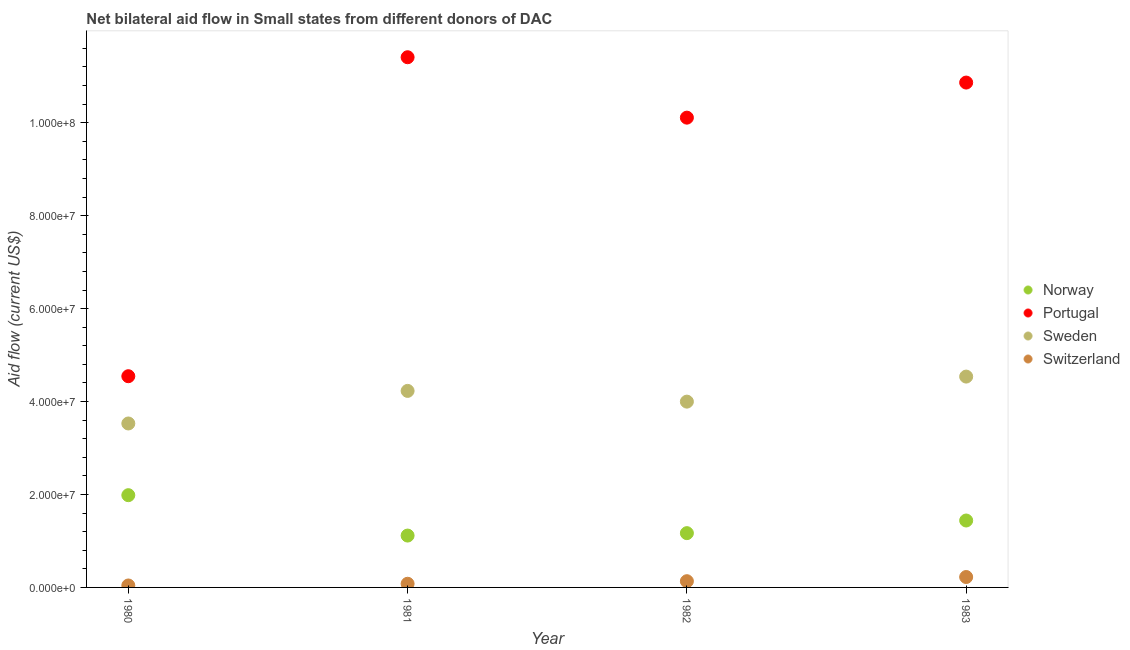What is the amount of aid given by switzerland in 1981?
Provide a succinct answer. 7.90e+05. Across all years, what is the maximum amount of aid given by sweden?
Offer a terse response. 4.54e+07. Across all years, what is the minimum amount of aid given by norway?
Make the answer very short. 1.12e+07. What is the total amount of aid given by portugal in the graph?
Your answer should be very brief. 3.69e+08. What is the difference between the amount of aid given by sweden in 1980 and that in 1983?
Make the answer very short. -1.01e+07. What is the difference between the amount of aid given by norway in 1981 and the amount of aid given by switzerland in 1983?
Make the answer very short. 8.92e+06. What is the average amount of aid given by portugal per year?
Offer a very short reply. 9.23e+07. In the year 1983, what is the difference between the amount of aid given by norway and amount of aid given by portugal?
Offer a very short reply. -9.42e+07. In how many years, is the amount of aid given by switzerland greater than 20000000 US$?
Make the answer very short. 0. What is the ratio of the amount of aid given by portugal in 1980 to that in 1982?
Ensure brevity in your answer.  0.45. Is the difference between the amount of aid given by sweden in 1980 and 1982 greater than the difference between the amount of aid given by norway in 1980 and 1982?
Your answer should be very brief. No. What is the difference between the highest and the lowest amount of aid given by sweden?
Keep it short and to the point. 1.01e+07. Is it the case that in every year, the sum of the amount of aid given by norway and amount of aid given by sweden is greater than the sum of amount of aid given by portugal and amount of aid given by switzerland?
Your response must be concise. Yes. Is the amount of aid given by sweden strictly less than the amount of aid given by portugal over the years?
Your response must be concise. Yes. How many years are there in the graph?
Give a very brief answer. 4. What is the difference between two consecutive major ticks on the Y-axis?
Provide a succinct answer. 2.00e+07. Are the values on the major ticks of Y-axis written in scientific E-notation?
Ensure brevity in your answer.  Yes. Does the graph contain any zero values?
Your answer should be very brief. No. Where does the legend appear in the graph?
Offer a very short reply. Center right. How many legend labels are there?
Keep it short and to the point. 4. How are the legend labels stacked?
Make the answer very short. Vertical. What is the title of the graph?
Offer a very short reply. Net bilateral aid flow in Small states from different donors of DAC. What is the label or title of the X-axis?
Ensure brevity in your answer.  Year. What is the label or title of the Y-axis?
Provide a succinct answer. Aid flow (current US$). What is the Aid flow (current US$) in Norway in 1980?
Provide a succinct answer. 1.98e+07. What is the Aid flow (current US$) of Portugal in 1980?
Ensure brevity in your answer.  4.54e+07. What is the Aid flow (current US$) of Sweden in 1980?
Your answer should be compact. 3.53e+07. What is the Aid flow (current US$) of Switzerland in 1980?
Your response must be concise. 4.20e+05. What is the Aid flow (current US$) in Norway in 1981?
Your answer should be compact. 1.12e+07. What is the Aid flow (current US$) in Portugal in 1981?
Make the answer very short. 1.14e+08. What is the Aid flow (current US$) of Sweden in 1981?
Your answer should be compact. 4.23e+07. What is the Aid flow (current US$) of Switzerland in 1981?
Make the answer very short. 7.90e+05. What is the Aid flow (current US$) of Norway in 1982?
Give a very brief answer. 1.17e+07. What is the Aid flow (current US$) in Portugal in 1982?
Offer a terse response. 1.01e+08. What is the Aid flow (current US$) of Sweden in 1982?
Offer a very short reply. 4.00e+07. What is the Aid flow (current US$) in Switzerland in 1982?
Provide a succinct answer. 1.34e+06. What is the Aid flow (current US$) in Norway in 1983?
Ensure brevity in your answer.  1.44e+07. What is the Aid flow (current US$) in Portugal in 1983?
Give a very brief answer. 1.09e+08. What is the Aid flow (current US$) of Sweden in 1983?
Ensure brevity in your answer.  4.54e+07. What is the Aid flow (current US$) of Switzerland in 1983?
Keep it short and to the point. 2.24e+06. Across all years, what is the maximum Aid flow (current US$) in Norway?
Keep it short and to the point. 1.98e+07. Across all years, what is the maximum Aid flow (current US$) in Portugal?
Keep it short and to the point. 1.14e+08. Across all years, what is the maximum Aid flow (current US$) of Sweden?
Offer a terse response. 4.54e+07. Across all years, what is the maximum Aid flow (current US$) in Switzerland?
Provide a succinct answer. 2.24e+06. Across all years, what is the minimum Aid flow (current US$) of Norway?
Your answer should be very brief. 1.12e+07. Across all years, what is the minimum Aid flow (current US$) in Portugal?
Offer a terse response. 4.54e+07. Across all years, what is the minimum Aid flow (current US$) in Sweden?
Ensure brevity in your answer.  3.53e+07. What is the total Aid flow (current US$) of Norway in the graph?
Provide a succinct answer. 5.71e+07. What is the total Aid flow (current US$) in Portugal in the graph?
Offer a very short reply. 3.69e+08. What is the total Aid flow (current US$) of Sweden in the graph?
Keep it short and to the point. 1.63e+08. What is the total Aid flow (current US$) in Switzerland in the graph?
Your answer should be compact. 4.79e+06. What is the difference between the Aid flow (current US$) of Norway in 1980 and that in 1981?
Offer a very short reply. 8.69e+06. What is the difference between the Aid flow (current US$) of Portugal in 1980 and that in 1981?
Your answer should be very brief. -6.86e+07. What is the difference between the Aid flow (current US$) of Sweden in 1980 and that in 1981?
Provide a short and direct response. -7.01e+06. What is the difference between the Aid flow (current US$) in Switzerland in 1980 and that in 1981?
Provide a succinct answer. -3.70e+05. What is the difference between the Aid flow (current US$) of Norway in 1980 and that in 1982?
Your answer should be compact. 8.17e+06. What is the difference between the Aid flow (current US$) of Portugal in 1980 and that in 1982?
Provide a short and direct response. -5.56e+07. What is the difference between the Aid flow (current US$) of Sweden in 1980 and that in 1982?
Your response must be concise. -4.70e+06. What is the difference between the Aid flow (current US$) in Switzerland in 1980 and that in 1982?
Your answer should be compact. -9.20e+05. What is the difference between the Aid flow (current US$) of Norway in 1980 and that in 1983?
Provide a short and direct response. 5.45e+06. What is the difference between the Aid flow (current US$) of Portugal in 1980 and that in 1983?
Your response must be concise. -6.32e+07. What is the difference between the Aid flow (current US$) of Sweden in 1980 and that in 1983?
Ensure brevity in your answer.  -1.01e+07. What is the difference between the Aid flow (current US$) in Switzerland in 1980 and that in 1983?
Your answer should be very brief. -1.82e+06. What is the difference between the Aid flow (current US$) in Norway in 1981 and that in 1982?
Make the answer very short. -5.20e+05. What is the difference between the Aid flow (current US$) of Portugal in 1981 and that in 1982?
Your answer should be compact. 1.30e+07. What is the difference between the Aid flow (current US$) of Sweden in 1981 and that in 1982?
Your answer should be compact. 2.31e+06. What is the difference between the Aid flow (current US$) in Switzerland in 1981 and that in 1982?
Your response must be concise. -5.50e+05. What is the difference between the Aid flow (current US$) of Norway in 1981 and that in 1983?
Give a very brief answer. -3.24e+06. What is the difference between the Aid flow (current US$) in Portugal in 1981 and that in 1983?
Your response must be concise. 5.45e+06. What is the difference between the Aid flow (current US$) in Sweden in 1981 and that in 1983?
Ensure brevity in your answer.  -3.08e+06. What is the difference between the Aid flow (current US$) in Switzerland in 1981 and that in 1983?
Offer a terse response. -1.45e+06. What is the difference between the Aid flow (current US$) of Norway in 1982 and that in 1983?
Ensure brevity in your answer.  -2.72e+06. What is the difference between the Aid flow (current US$) in Portugal in 1982 and that in 1983?
Your answer should be compact. -7.55e+06. What is the difference between the Aid flow (current US$) in Sweden in 1982 and that in 1983?
Make the answer very short. -5.39e+06. What is the difference between the Aid flow (current US$) in Switzerland in 1982 and that in 1983?
Keep it short and to the point. -9.00e+05. What is the difference between the Aid flow (current US$) of Norway in 1980 and the Aid flow (current US$) of Portugal in 1981?
Your answer should be compact. -9.42e+07. What is the difference between the Aid flow (current US$) of Norway in 1980 and the Aid flow (current US$) of Sweden in 1981?
Offer a very short reply. -2.24e+07. What is the difference between the Aid flow (current US$) of Norway in 1980 and the Aid flow (current US$) of Switzerland in 1981?
Your answer should be compact. 1.91e+07. What is the difference between the Aid flow (current US$) in Portugal in 1980 and the Aid flow (current US$) in Sweden in 1981?
Keep it short and to the point. 3.16e+06. What is the difference between the Aid flow (current US$) in Portugal in 1980 and the Aid flow (current US$) in Switzerland in 1981?
Keep it short and to the point. 4.47e+07. What is the difference between the Aid flow (current US$) in Sweden in 1980 and the Aid flow (current US$) in Switzerland in 1981?
Ensure brevity in your answer.  3.45e+07. What is the difference between the Aid flow (current US$) of Norway in 1980 and the Aid flow (current US$) of Portugal in 1982?
Provide a short and direct response. -8.12e+07. What is the difference between the Aid flow (current US$) of Norway in 1980 and the Aid flow (current US$) of Sweden in 1982?
Give a very brief answer. -2.01e+07. What is the difference between the Aid flow (current US$) in Norway in 1980 and the Aid flow (current US$) in Switzerland in 1982?
Make the answer very short. 1.85e+07. What is the difference between the Aid flow (current US$) of Portugal in 1980 and the Aid flow (current US$) of Sweden in 1982?
Provide a succinct answer. 5.47e+06. What is the difference between the Aid flow (current US$) in Portugal in 1980 and the Aid flow (current US$) in Switzerland in 1982?
Offer a very short reply. 4.41e+07. What is the difference between the Aid flow (current US$) of Sweden in 1980 and the Aid flow (current US$) of Switzerland in 1982?
Your response must be concise. 3.39e+07. What is the difference between the Aid flow (current US$) in Norway in 1980 and the Aid flow (current US$) in Portugal in 1983?
Keep it short and to the point. -8.88e+07. What is the difference between the Aid flow (current US$) in Norway in 1980 and the Aid flow (current US$) in Sweden in 1983?
Provide a short and direct response. -2.55e+07. What is the difference between the Aid flow (current US$) in Norway in 1980 and the Aid flow (current US$) in Switzerland in 1983?
Offer a terse response. 1.76e+07. What is the difference between the Aid flow (current US$) of Portugal in 1980 and the Aid flow (current US$) of Sweden in 1983?
Your answer should be compact. 8.00e+04. What is the difference between the Aid flow (current US$) in Portugal in 1980 and the Aid flow (current US$) in Switzerland in 1983?
Provide a short and direct response. 4.32e+07. What is the difference between the Aid flow (current US$) of Sweden in 1980 and the Aid flow (current US$) of Switzerland in 1983?
Provide a succinct answer. 3.30e+07. What is the difference between the Aid flow (current US$) of Norway in 1981 and the Aid flow (current US$) of Portugal in 1982?
Your answer should be very brief. -8.99e+07. What is the difference between the Aid flow (current US$) in Norway in 1981 and the Aid flow (current US$) in Sweden in 1982?
Ensure brevity in your answer.  -2.88e+07. What is the difference between the Aid flow (current US$) of Norway in 1981 and the Aid flow (current US$) of Switzerland in 1982?
Keep it short and to the point. 9.82e+06. What is the difference between the Aid flow (current US$) in Portugal in 1981 and the Aid flow (current US$) in Sweden in 1982?
Your response must be concise. 7.41e+07. What is the difference between the Aid flow (current US$) in Portugal in 1981 and the Aid flow (current US$) in Switzerland in 1982?
Keep it short and to the point. 1.13e+08. What is the difference between the Aid flow (current US$) in Sweden in 1981 and the Aid flow (current US$) in Switzerland in 1982?
Offer a very short reply. 4.10e+07. What is the difference between the Aid flow (current US$) of Norway in 1981 and the Aid flow (current US$) of Portugal in 1983?
Your response must be concise. -9.75e+07. What is the difference between the Aid flow (current US$) in Norway in 1981 and the Aid flow (current US$) in Sweden in 1983?
Provide a short and direct response. -3.42e+07. What is the difference between the Aid flow (current US$) in Norway in 1981 and the Aid flow (current US$) in Switzerland in 1983?
Give a very brief answer. 8.92e+06. What is the difference between the Aid flow (current US$) of Portugal in 1981 and the Aid flow (current US$) of Sweden in 1983?
Provide a short and direct response. 6.87e+07. What is the difference between the Aid flow (current US$) in Portugal in 1981 and the Aid flow (current US$) in Switzerland in 1983?
Provide a succinct answer. 1.12e+08. What is the difference between the Aid flow (current US$) in Sweden in 1981 and the Aid flow (current US$) in Switzerland in 1983?
Keep it short and to the point. 4.00e+07. What is the difference between the Aid flow (current US$) in Norway in 1982 and the Aid flow (current US$) in Portugal in 1983?
Your response must be concise. -9.70e+07. What is the difference between the Aid flow (current US$) in Norway in 1982 and the Aid flow (current US$) in Sweden in 1983?
Provide a succinct answer. -3.37e+07. What is the difference between the Aid flow (current US$) in Norway in 1982 and the Aid flow (current US$) in Switzerland in 1983?
Your answer should be compact. 9.44e+06. What is the difference between the Aid flow (current US$) of Portugal in 1982 and the Aid flow (current US$) of Sweden in 1983?
Keep it short and to the point. 5.57e+07. What is the difference between the Aid flow (current US$) of Portugal in 1982 and the Aid flow (current US$) of Switzerland in 1983?
Make the answer very short. 9.88e+07. What is the difference between the Aid flow (current US$) of Sweden in 1982 and the Aid flow (current US$) of Switzerland in 1983?
Provide a succinct answer. 3.77e+07. What is the average Aid flow (current US$) in Norway per year?
Your answer should be very brief. 1.43e+07. What is the average Aid flow (current US$) in Portugal per year?
Your response must be concise. 9.23e+07. What is the average Aid flow (current US$) in Sweden per year?
Your answer should be very brief. 4.07e+07. What is the average Aid flow (current US$) of Switzerland per year?
Provide a succinct answer. 1.20e+06. In the year 1980, what is the difference between the Aid flow (current US$) in Norway and Aid flow (current US$) in Portugal?
Your response must be concise. -2.56e+07. In the year 1980, what is the difference between the Aid flow (current US$) in Norway and Aid flow (current US$) in Sweden?
Your answer should be compact. -1.54e+07. In the year 1980, what is the difference between the Aid flow (current US$) in Norway and Aid flow (current US$) in Switzerland?
Offer a terse response. 1.94e+07. In the year 1980, what is the difference between the Aid flow (current US$) of Portugal and Aid flow (current US$) of Sweden?
Keep it short and to the point. 1.02e+07. In the year 1980, what is the difference between the Aid flow (current US$) of Portugal and Aid flow (current US$) of Switzerland?
Give a very brief answer. 4.50e+07. In the year 1980, what is the difference between the Aid flow (current US$) of Sweden and Aid flow (current US$) of Switzerland?
Ensure brevity in your answer.  3.49e+07. In the year 1981, what is the difference between the Aid flow (current US$) in Norway and Aid flow (current US$) in Portugal?
Provide a succinct answer. -1.03e+08. In the year 1981, what is the difference between the Aid flow (current US$) in Norway and Aid flow (current US$) in Sweden?
Provide a short and direct response. -3.11e+07. In the year 1981, what is the difference between the Aid flow (current US$) in Norway and Aid flow (current US$) in Switzerland?
Keep it short and to the point. 1.04e+07. In the year 1981, what is the difference between the Aid flow (current US$) of Portugal and Aid flow (current US$) of Sweden?
Ensure brevity in your answer.  7.18e+07. In the year 1981, what is the difference between the Aid flow (current US$) of Portugal and Aid flow (current US$) of Switzerland?
Give a very brief answer. 1.13e+08. In the year 1981, what is the difference between the Aid flow (current US$) of Sweden and Aid flow (current US$) of Switzerland?
Offer a terse response. 4.15e+07. In the year 1982, what is the difference between the Aid flow (current US$) of Norway and Aid flow (current US$) of Portugal?
Offer a terse response. -8.94e+07. In the year 1982, what is the difference between the Aid flow (current US$) in Norway and Aid flow (current US$) in Sweden?
Your answer should be very brief. -2.83e+07. In the year 1982, what is the difference between the Aid flow (current US$) in Norway and Aid flow (current US$) in Switzerland?
Your answer should be compact. 1.03e+07. In the year 1982, what is the difference between the Aid flow (current US$) in Portugal and Aid flow (current US$) in Sweden?
Give a very brief answer. 6.11e+07. In the year 1982, what is the difference between the Aid flow (current US$) of Portugal and Aid flow (current US$) of Switzerland?
Your response must be concise. 9.98e+07. In the year 1982, what is the difference between the Aid flow (current US$) of Sweden and Aid flow (current US$) of Switzerland?
Your answer should be very brief. 3.86e+07. In the year 1983, what is the difference between the Aid flow (current US$) of Norway and Aid flow (current US$) of Portugal?
Keep it short and to the point. -9.42e+07. In the year 1983, what is the difference between the Aid flow (current US$) of Norway and Aid flow (current US$) of Sweden?
Offer a very short reply. -3.10e+07. In the year 1983, what is the difference between the Aid flow (current US$) in Norway and Aid flow (current US$) in Switzerland?
Ensure brevity in your answer.  1.22e+07. In the year 1983, what is the difference between the Aid flow (current US$) in Portugal and Aid flow (current US$) in Sweden?
Your answer should be compact. 6.33e+07. In the year 1983, what is the difference between the Aid flow (current US$) in Portugal and Aid flow (current US$) in Switzerland?
Your answer should be very brief. 1.06e+08. In the year 1983, what is the difference between the Aid flow (current US$) in Sweden and Aid flow (current US$) in Switzerland?
Ensure brevity in your answer.  4.31e+07. What is the ratio of the Aid flow (current US$) of Norway in 1980 to that in 1981?
Provide a succinct answer. 1.78. What is the ratio of the Aid flow (current US$) of Portugal in 1980 to that in 1981?
Ensure brevity in your answer.  0.4. What is the ratio of the Aid flow (current US$) of Sweden in 1980 to that in 1981?
Ensure brevity in your answer.  0.83. What is the ratio of the Aid flow (current US$) in Switzerland in 1980 to that in 1981?
Your response must be concise. 0.53. What is the ratio of the Aid flow (current US$) in Norway in 1980 to that in 1982?
Your answer should be very brief. 1.7. What is the ratio of the Aid flow (current US$) of Portugal in 1980 to that in 1982?
Make the answer very short. 0.45. What is the ratio of the Aid flow (current US$) of Sweden in 1980 to that in 1982?
Give a very brief answer. 0.88. What is the ratio of the Aid flow (current US$) in Switzerland in 1980 to that in 1982?
Make the answer very short. 0.31. What is the ratio of the Aid flow (current US$) in Norway in 1980 to that in 1983?
Make the answer very short. 1.38. What is the ratio of the Aid flow (current US$) in Portugal in 1980 to that in 1983?
Keep it short and to the point. 0.42. What is the ratio of the Aid flow (current US$) of Sweden in 1980 to that in 1983?
Provide a short and direct response. 0.78. What is the ratio of the Aid flow (current US$) in Switzerland in 1980 to that in 1983?
Provide a succinct answer. 0.19. What is the ratio of the Aid flow (current US$) in Norway in 1981 to that in 1982?
Keep it short and to the point. 0.96. What is the ratio of the Aid flow (current US$) of Portugal in 1981 to that in 1982?
Offer a terse response. 1.13. What is the ratio of the Aid flow (current US$) in Sweden in 1981 to that in 1982?
Make the answer very short. 1.06. What is the ratio of the Aid flow (current US$) in Switzerland in 1981 to that in 1982?
Offer a very short reply. 0.59. What is the ratio of the Aid flow (current US$) of Norway in 1981 to that in 1983?
Provide a succinct answer. 0.78. What is the ratio of the Aid flow (current US$) in Portugal in 1981 to that in 1983?
Keep it short and to the point. 1.05. What is the ratio of the Aid flow (current US$) in Sweden in 1981 to that in 1983?
Your answer should be compact. 0.93. What is the ratio of the Aid flow (current US$) in Switzerland in 1981 to that in 1983?
Provide a short and direct response. 0.35. What is the ratio of the Aid flow (current US$) of Norway in 1982 to that in 1983?
Offer a terse response. 0.81. What is the ratio of the Aid flow (current US$) in Portugal in 1982 to that in 1983?
Keep it short and to the point. 0.93. What is the ratio of the Aid flow (current US$) of Sweden in 1982 to that in 1983?
Your response must be concise. 0.88. What is the ratio of the Aid flow (current US$) in Switzerland in 1982 to that in 1983?
Make the answer very short. 0.6. What is the difference between the highest and the second highest Aid flow (current US$) of Norway?
Your answer should be very brief. 5.45e+06. What is the difference between the highest and the second highest Aid flow (current US$) in Portugal?
Your answer should be very brief. 5.45e+06. What is the difference between the highest and the second highest Aid flow (current US$) in Sweden?
Your answer should be compact. 3.08e+06. What is the difference between the highest and the lowest Aid flow (current US$) in Norway?
Your answer should be very brief. 8.69e+06. What is the difference between the highest and the lowest Aid flow (current US$) in Portugal?
Keep it short and to the point. 6.86e+07. What is the difference between the highest and the lowest Aid flow (current US$) in Sweden?
Make the answer very short. 1.01e+07. What is the difference between the highest and the lowest Aid flow (current US$) in Switzerland?
Your answer should be very brief. 1.82e+06. 